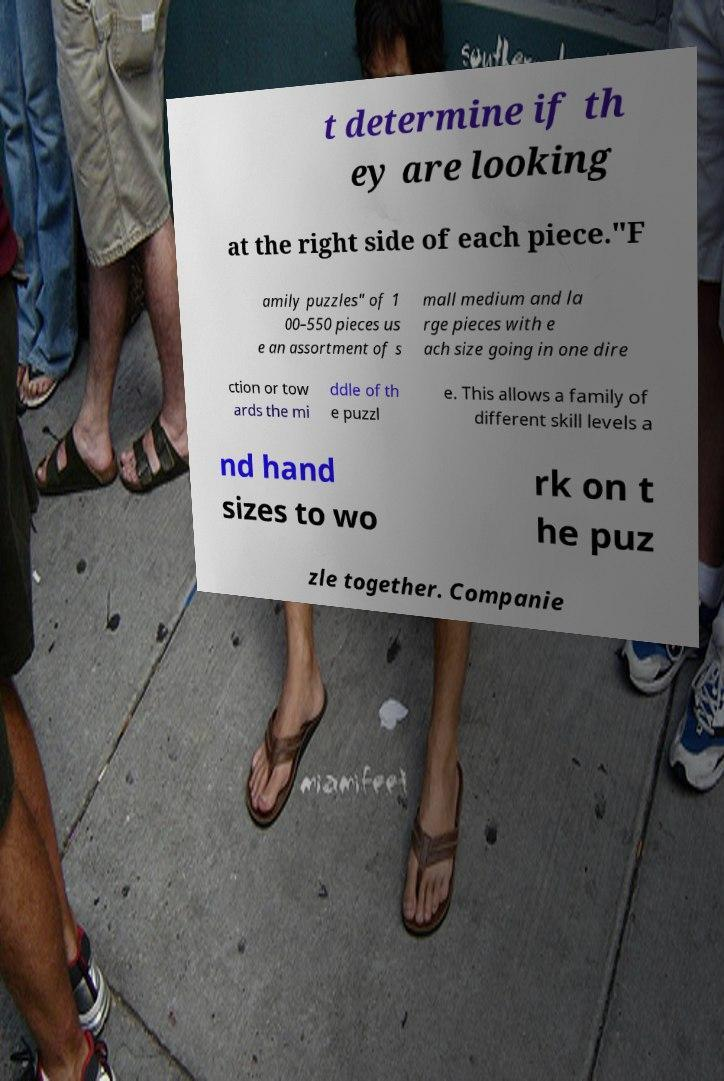Can you accurately transcribe the text from the provided image for me? t determine if th ey are looking at the right side of each piece."F amily puzzles" of 1 00–550 pieces us e an assortment of s mall medium and la rge pieces with e ach size going in one dire ction or tow ards the mi ddle of th e puzzl e. This allows a family of different skill levels a nd hand sizes to wo rk on t he puz zle together. Companie 